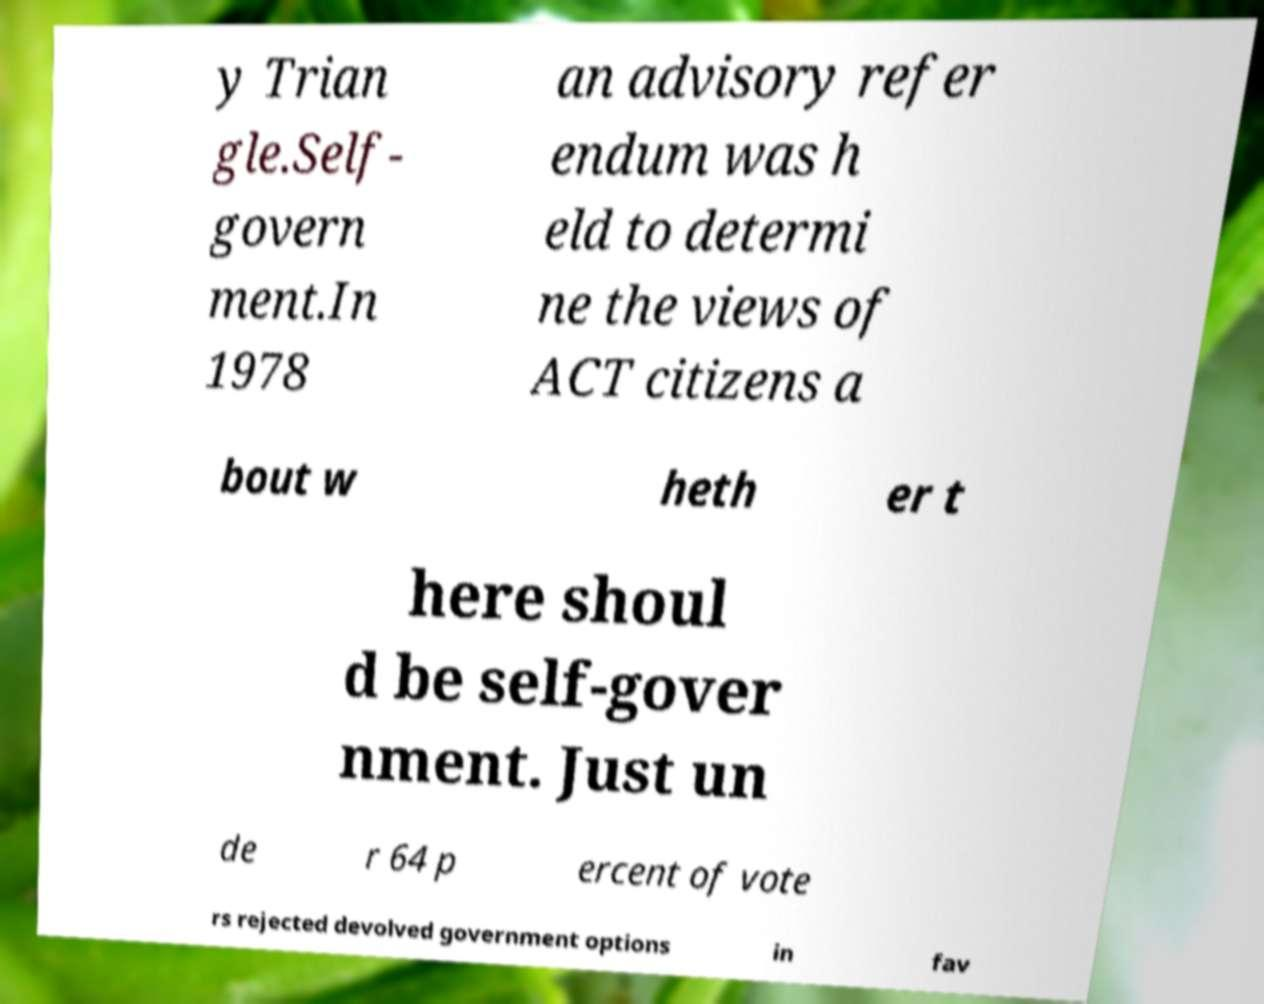There's text embedded in this image that I need extracted. Can you transcribe it verbatim? y Trian gle.Self- govern ment.In 1978 an advisory refer endum was h eld to determi ne the views of ACT citizens a bout w heth er t here shoul d be self-gover nment. Just un de r 64 p ercent of vote rs rejected devolved government options in fav 